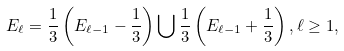<formula> <loc_0><loc_0><loc_500><loc_500>E _ { \ell } = \frac { 1 } { 3 } \left ( E _ { \ell - 1 } - \frac { 1 } { 3 } \right ) \bigcup \frac { 1 } { 3 } \left ( E _ { \ell - 1 } + \frac { 1 } { 3 } \right ) , \ell \geq 1 ,</formula> 